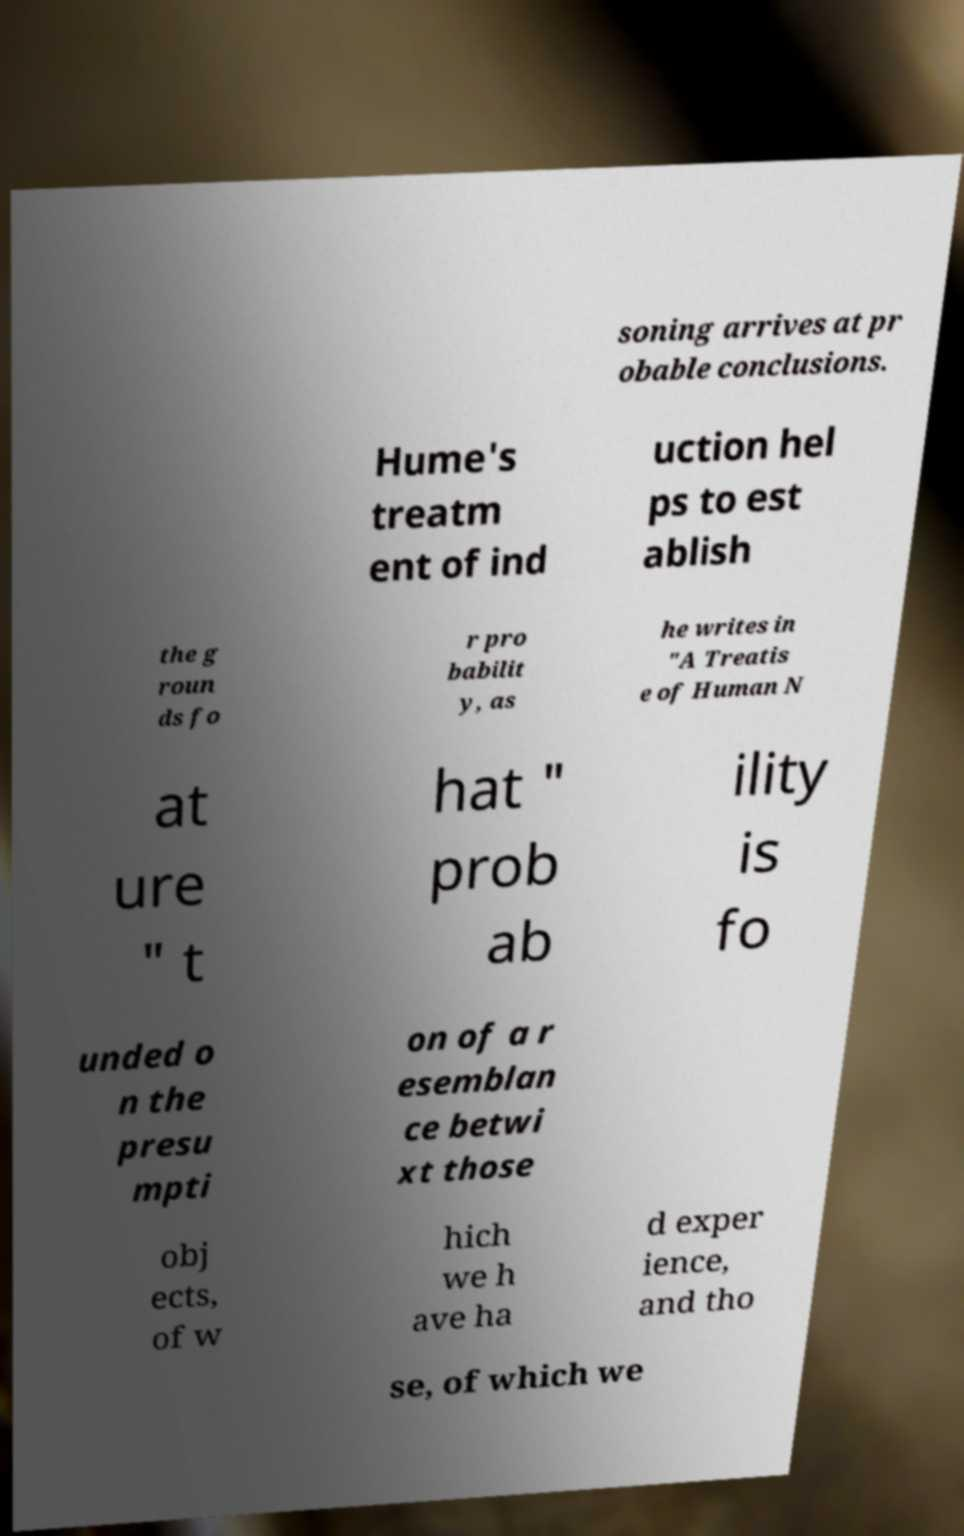I need the written content from this picture converted into text. Can you do that? soning arrives at pr obable conclusions. Hume's treatm ent of ind uction hel ps to est ablish the g roun ds fo r pro babilit y, as he writes in "A Treatis e of Human N at ure " t hat " prob ab ility is fo unded o n the presu mpti on of a r esemblan ce betwi xt those obj ects, of w hich we h ave ha d exper ience, and tho se, of which we 